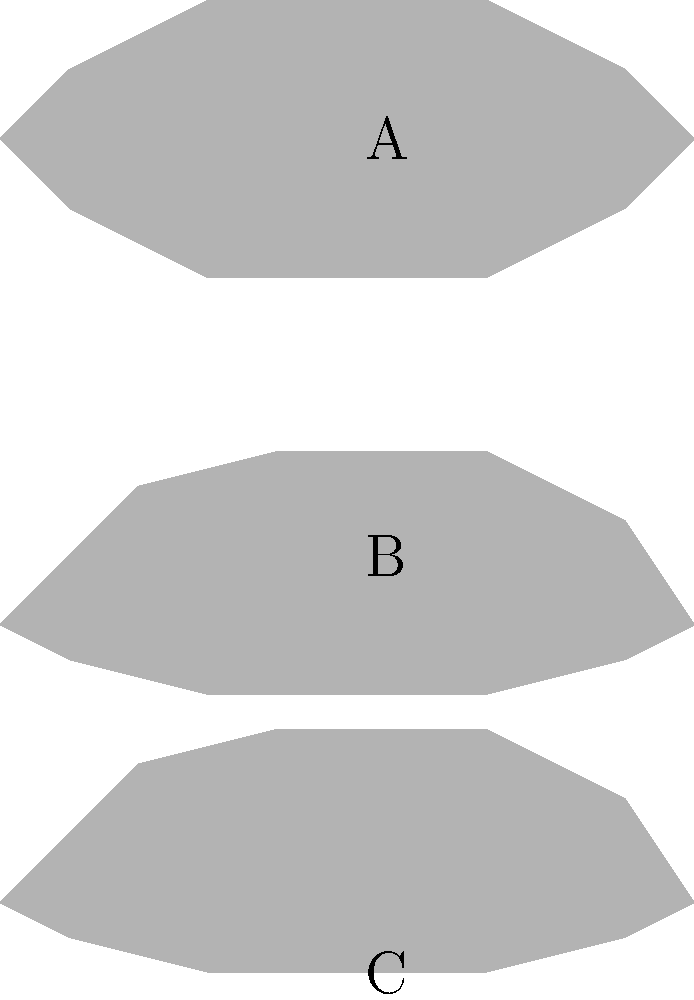As a novice motorbike racer enthusiast, you're working on a machine learning project to classify motorcycle types based on their silhouettes. Given the three silhouettes above, which one represents a dirt bike, and what features would you use to train your model to identify it? To answer this question and train a machine learning model to classify motorcycle types based on silhouettes, we need to analyze the distinctive features of each type:

1. Silhouette A: This represents a sport bike. It has a sleek, aerodynamic profile with a low front end and a raised rear, optimized for speed and agility.

2. Silhouette B: This shows a cruiser bike. It has a lower overall profile with a more relaxed seating position, characterized by a lower seat height and a more rounded shape.

3. Silhouette C: This is the dirt bike silhouette. It has several distinctive features:
   a) Higher ground clearance: The entire silhouette sits higher off the ground.
   b) Elevated seat position: The seat line is noticeably higher than the other two.
   c) Pronounced front fender: The front part of the silhouette extends higher, indicating a larger front fender for mud protection.
   d) Upright handlebar position: The handlebars appear to be higher and more upright.

To train a machine learning model to identify dirt bikes, you would focus on these key features:

1. Overall height of the silhouette
2. Ground clearance (distance from the bottom of the silhouette to the ground)
3. Seat height relative to the overall silhouette
4. Front fender height and prominence
5. Handlebar position and height

The model could be trained to recognize these features using techniques such as edge detection, feature extraction, and convolutional neural networks (CNNs) that are particularly effective for image classification tasks.
Answer: Silhouette C; key features: high ground clearance, elevated seat, pronounced front fender, upright handlebars. 